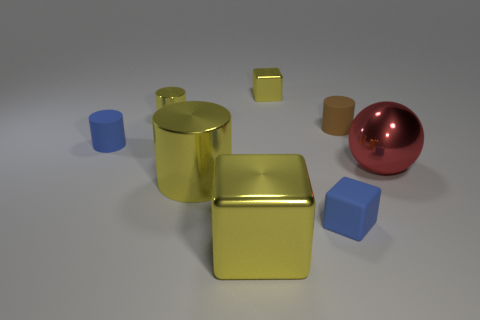There is a blue object left of the tiny blue rubber object in front of the blue matte cylinder; what is it made of?
Offer a terse response. Rubber. There is a tiny metal object that is the same color as the small shiny cylinder; what is its shape?
Your response must be concise. Cube. The blue thing that is the same size as the blue matte cylinder is what shape?
Keep it short and to the point. Cube. Are there fewer objects than blue matte cylinders?
Provide a succinct answer. No. There is a small cube behind the big red ball; is there a blue object that is left of it?
Give a very brief answer. Yes. There is a red object that is the same material as the big block; what is its shape?
Provide a short and direct response. Sphere. Is there any other thing that is the same color as the large shiny sphere?
Provide a short and direct response. No. What is the material of the tiny blue thing that is the same shape as the small brown rubber object?
Offer a very short reply. Rubber. How many other things are the same size as the blue cube?
Give a very brief answer. 4. There is a rubber object that is the same color as the rubber cube; what is its size?
Your response must be concise. Small. 